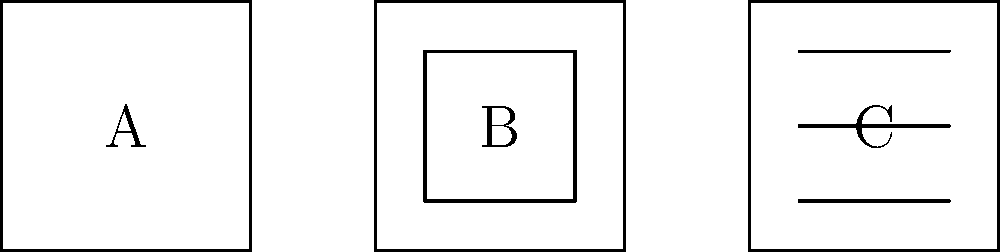Match the following encryption methods to their corresponding visual representations (A, B, C) shown in the diagram:

1. Symmetric Encryption
2. Asymmetric Encryption
3. Hash Function Let's analyze each visual representation and match it to the corresponding encryption method:

1. Visual A: This is a simple square, representing a single key used for both encryption and decryption. This corresponds to Symmetric Encryption, where the same key is used to encrypt and decrypt data.

2. Visual B: This shows a square within a square, representing two different keys - one for encryption (outer square) and one for decryption (inner square). This corresponds to Asymmetric Encryption, which uses a public key for encryption and a private key for decryption.

3. Visual C: This depicts a square with multiple horizontal lines, representing the conversion of input data into a fixed-size output. This corresponds to a Hash Function, which takes an input of any size and produces a fixed-size output.

Therefore, the correct matches are:
1. Symmetric Encryption - A
2. Asymmetric Encryption - B
3. Hash Function - C
Answer: 1-A, 2-B, 3-C 